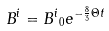<formula> <loc_0><loc_0><loc_500><loc_500>B ^ { i } = { B ^ { i } } _ { 0 } e ^ { - \frac { 8 } { 3 } { \Theta } t }</formula> 